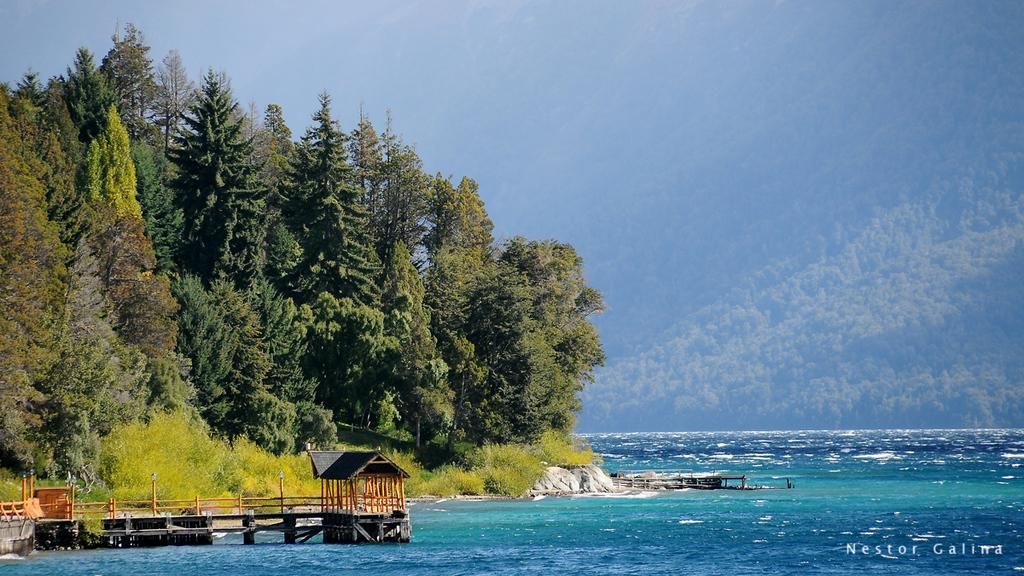What is visible in the image? Water, a bridge, rocks, and trees are visible in the image. Can you describe the bridge in the image? The bridge is beside the water. What type of natural elements are present near the water? Rocks and trees are present near the water. Are there any plants visible in the image? Yes, plants are visible in the image. Can you describe the arrangement of the trees in the image? There is a group of trees near the water and another group of trees behind the water. What type of transport is being used by the men in the image? There are no men or any form of transport present in the image. What is the source of shame for the trees in the image? There is no indication of shame in the image, and trees do not experience emotions like shame. 